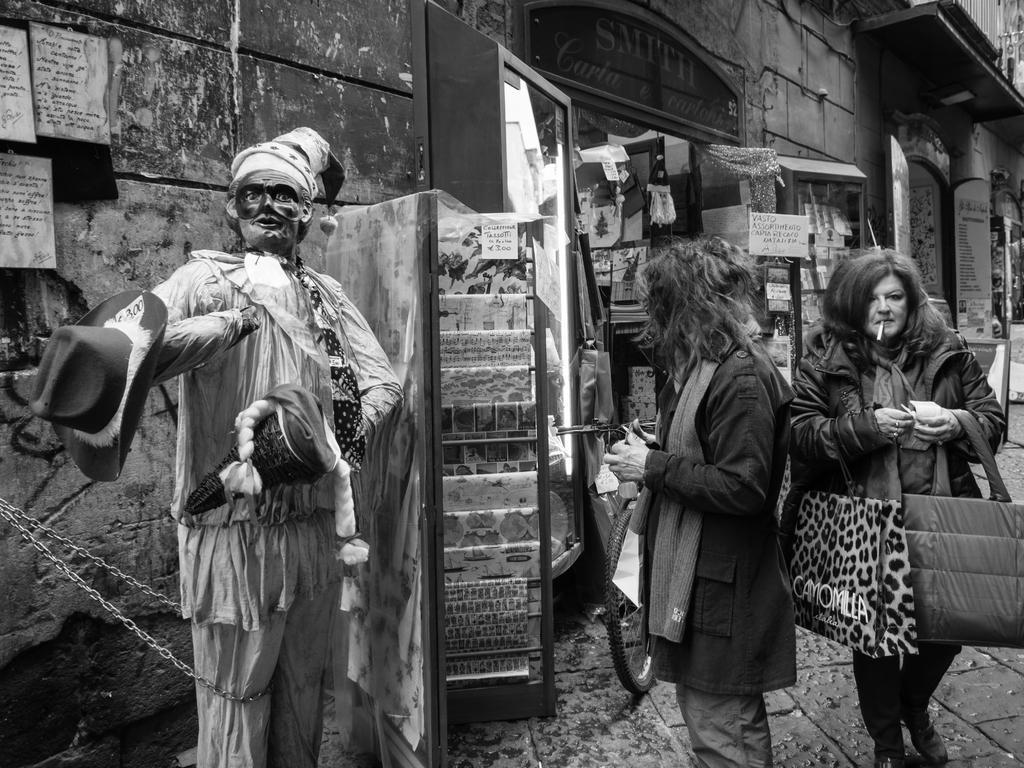Can you describe this image briefly? It is a black and white image there are few stores beside the footpath and there is a mannequin on the left side, there are two women standing in front a store beside the mannequin and the second woman is holding two bags. 